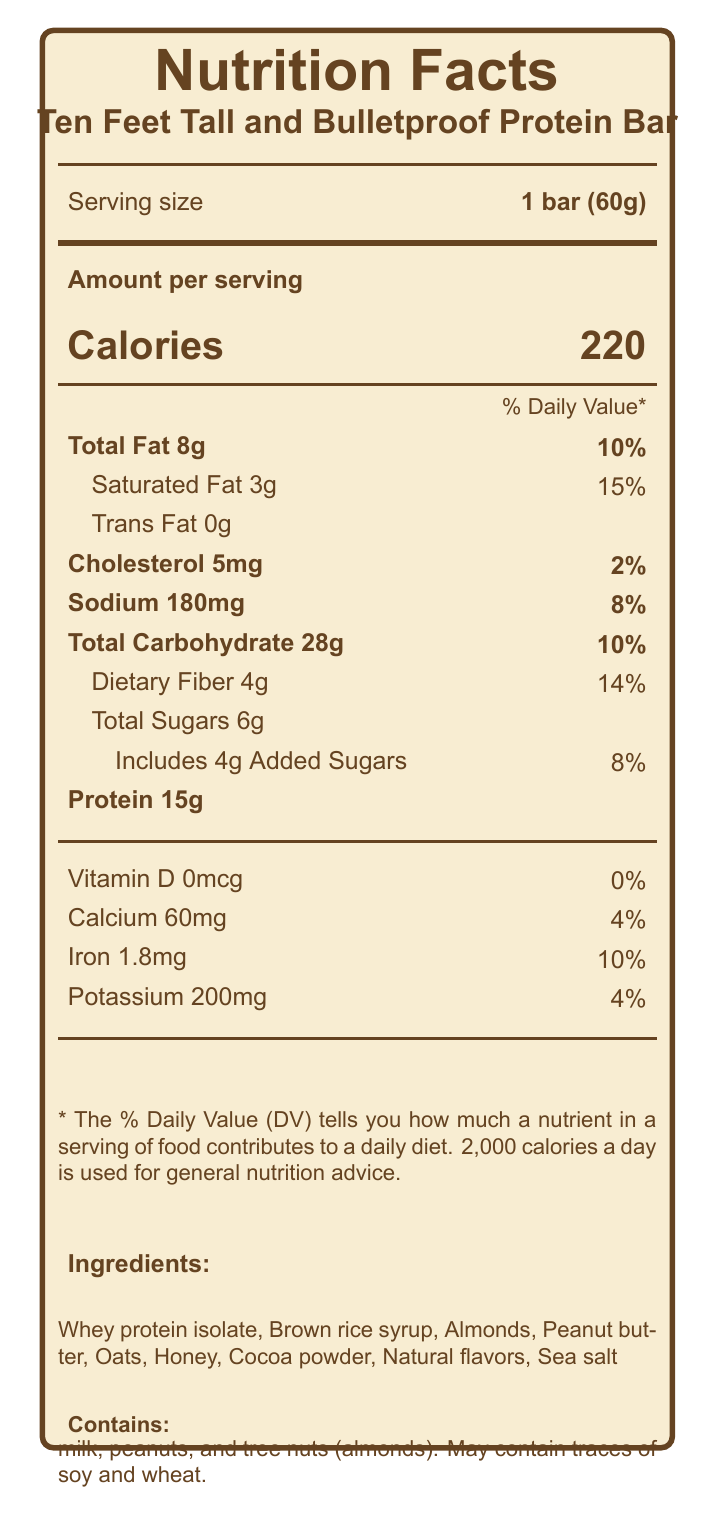what is the serving size? The document specifies that the serving size is 1 bar weighing 60 grams.
Answer: 1 bar (60g) what is the total fat content per serving? According to the document, the total fat content per serving is listed as 8 grams.
Answer: 8g how many grams of protein are there per serving? The document states that there are 15 grams of protein per serving.
Answer: 15g how much sodium is in one serving of the protein bar? The amount of sodium in one serving is 180mg, as specified in the document.
Answer: 180mg how many servings are in one container? The document mentions that the container has 12 servings.
Answer: 12 what percentage of the daily value of calcium does one serving provide? One serving provides 4% of the daily value of calcium.
Answer: 4% What is the amount of total carbohydrates in one serving? A. 10g B. 18g C. 28g D. 38g The document lists the total carbohydrate content per serving as 28 grams.
Answer: C Which of the following ingredients is NOT listed in the protein bar? A. Whey protein isolate B. Brown rice syrup C. High fructose corn syrup D. Peanut butter The listed ingredients do not include high fructose corn syrup.
Answer: C does the protein bar contain any trans fat? The document states that the trans fat content is 0 grams.
Answer: No Is there any added sugar in the protein bar? The document indicates that there are 4 grams of added sugars in the protein bar.
Answer: Yes summarize the nutrition information provided for the "Ten Feet Tall and Bulletproof" Protein Bar. This summary captures the key nutritional facts and ingredient information provided in the document.
Answer: The "Ten Feet Tall and Bulletproof" Protein Bar has 220 calories per serving (1 bar, 60g). Each serving contains 8g of total fat (10% daily value), with 3g of saturated fat (15% daily value) and 0g of trans fat. It also has 5mg of cholesterol (2% daily value), 180mg of sodium (8% daily value), 28g of total carbohydrates (10% daily value), 4g of dietary fiber (14% daily value), 6g of total sugars including 4g of added sugars (8% daily value), and 15g of protein. The bar provides 0% of the daily value for vitamin D, 4% for calcium, 10% for iron, and 4% for potassium. The ingredients include whey protein isolate, brown rice syrup, almonds, peanut butter, oats, honey, cocoa powder, natural flavors, and sea salt. It contains allergens such as milk, peanuts, and tree nuts (almonds) and may contain traces of soy and wheat. what is the intended use for this protein bar according to the marketing claims? The marketing claims specify that the protein bar is perfect for providing an energy boost before concerts.
Answer: Pre-concert snacking where is the protein bar manufactured? The document states that the protein bar is manufactured in Nashville, Tennessee.
Answer: Nashville, Tennessee what are the main allergens present in the protein bar? The allergen information section lists milk, peanuts, and tree nuts (almonds) as the main allergens.
Answer: Milk, peanuts, almonds When should the protein bar be consumed according to the storage instructions? The document suggests that it's best consumed before attending a Travis Tritt concert.
Answer: Before attending a Travis Tritt concert who is the manufacturer of the protein bar? The document lists Country Roads Nutrition, LLC, as the manufacturer of the protein bar.
Answer: Country Roads Nutrition, LLC what is the shelf life of the protein bar? The document does not provide any information regarding the shelf life of the protein bar.
Answer: Not enough information 